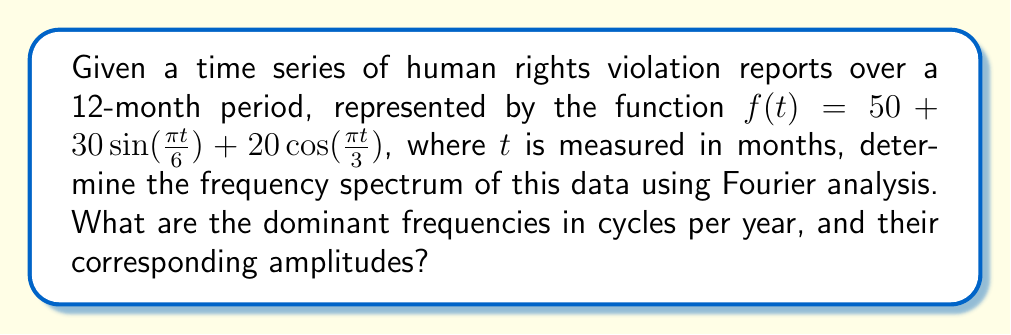Can you answer this question? To determine the frequency spectrum, we need to analyze the given function:

$f(t) = 50 + 30\sin(\frac{\pi t}{6}) + 20\cos(\frac{\pi t}{3})$

1. Identify the components:
   - Constant term: 50
   - Sinusoidal terms: $30\sin(\frac{\pi t}{6})$ and $20\cos(\frac{\pi t}{3})$

2. Analyze the frequencies:
   - For $\sin(\frac{\pi t}{6})$:
     Frequency = $\frac{1}{12}$ cycles/month = $\frac{1}{1}$ = 1 cycle/year
   - For $\cos(\frac{\pi t}{3})$:
     Frequency = $\frac{1}{6}$ cycles/month = $\frac{2}{1}$ = 2 cycles/year

3. Determine the amplitudes:
   - For the 1 cycle/year component: 30
   - For the 2 cycles/year component: 20

4. The constant term (50) represents the DC component or 0 frequency.

Therefore, the frequency spectrum consists of three main components:
0 cycles/year (DC), 1 cycle/year, and 2 cycles/year.
Answer: Dominant frequencies: 0 cycles/year (amplitude 50), 1 cycle/year (amplitude 30), 2 cycles/year (amplitude 20) 